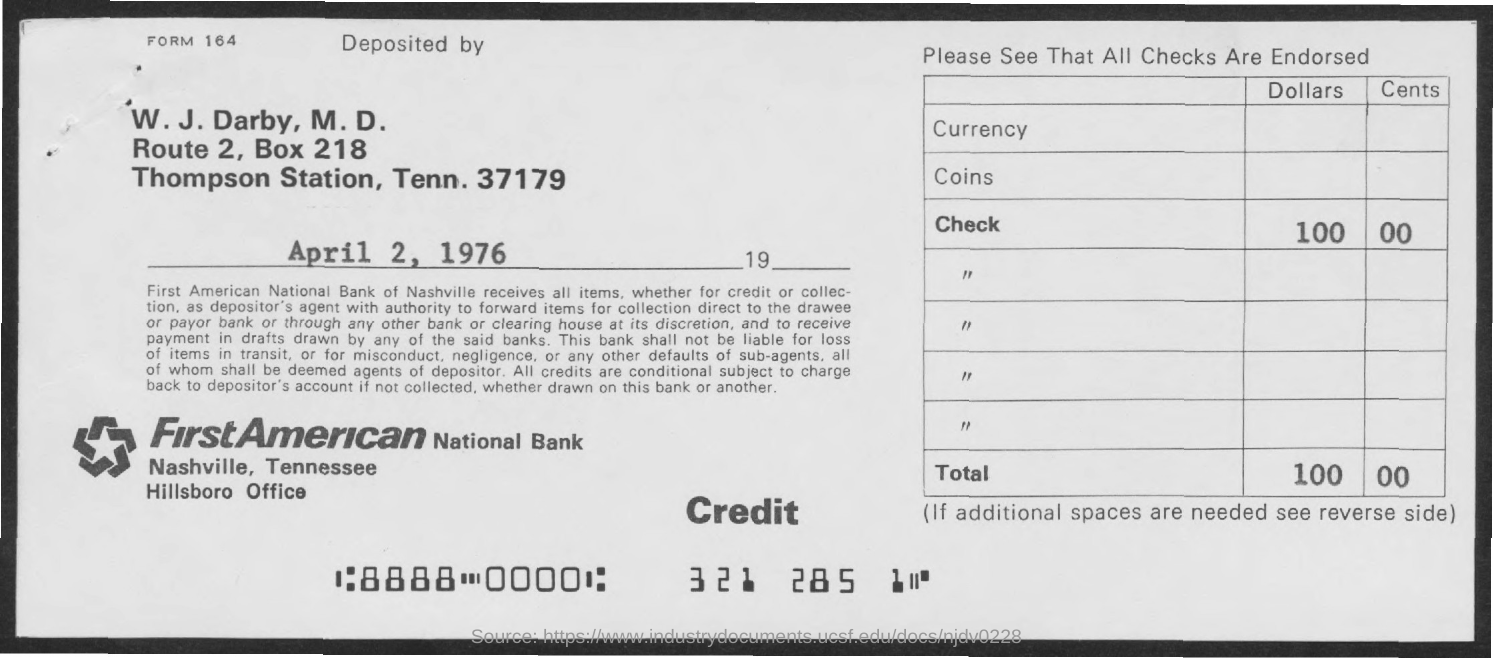When is the memorandum dated on ?
Offer a very short reply. April 2, 1976. What is the Bank Name ?
Provide a short and direct response. FirstAmerican National Bank. What is the BOX Number ?
Provide a succinct answer. 218. 